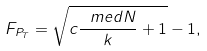Convert formula to latex. <formula><loc_0><loc_0><loc_500><loc_500>F _ { P _ { T } } = \sqrt { c \frac { \ m e d { N } } { k } + 1 } - 1 ,</formula> 